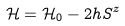<formula> <loc_0><loc_0><loc_500><loc_500>\mathcal { H } = \mathcal { H } _ { 0 } - 2 h S ^ { z }</formula> 